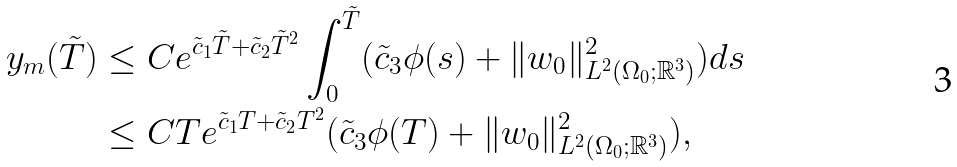Convert formula to latex. <formula><loc_0><loc_0><loc_500><loc_500>y _ { m } ( \tilde { T } ) & \leq C e ^ { \tilde { c } _ { 1 } \tilde { T } + \tilde { c } _ { 2 } \tilde { T } ^ { 2 } } \int _ { 0 } ^ { \tilde { T } } ( \tilde { c } _ { 3 } \phi ( s ) + \| w _ { 0 } \| ^ { 2 } _ { L ^ { 2 } ( \Omega _ { 0 } ; { \mathbb { R } } ^ { 3 } ) } ) d s \\ & \leq C T e ^ { \tilde { c } _ { 1 } T + \tilde { c } _ { 2 } T ^ { 2 } } ( \tilde { c } _ { 3 } \phi ( T ) + \| w _ { 0 } \| ^ { 2 } _ { L ^ { 2 } ( \Omega _ { 0 } ; { \mathbb { R } } ^ { 3 } ) } ) ,</formula> 